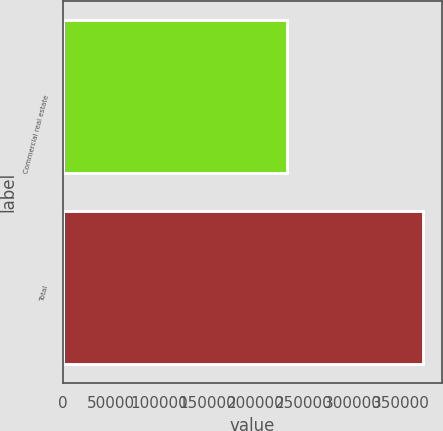Convert chart to OTSL. <chart><loc_0><loc_0><loc_500><loc_500><bar_chart><fcel>Commercial real estate<fcel>Total<nl><fcel>232151<fcel>373639<nl></chart> 